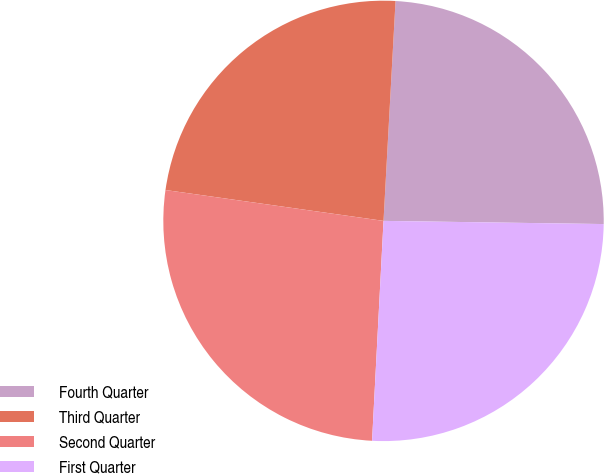Convert chart to OTSL. <chart><loc_0><loc_0><loc_500><loc_500><pie_chart><fcel>Fourth Quarter<fcel>Third Quarter<fcel>Second Quarter<fcel>First Quarter<nl><fcel>24.36%<fcel>23.63%<fcel>26.41%<fcel>25.6%<nl></chart> 